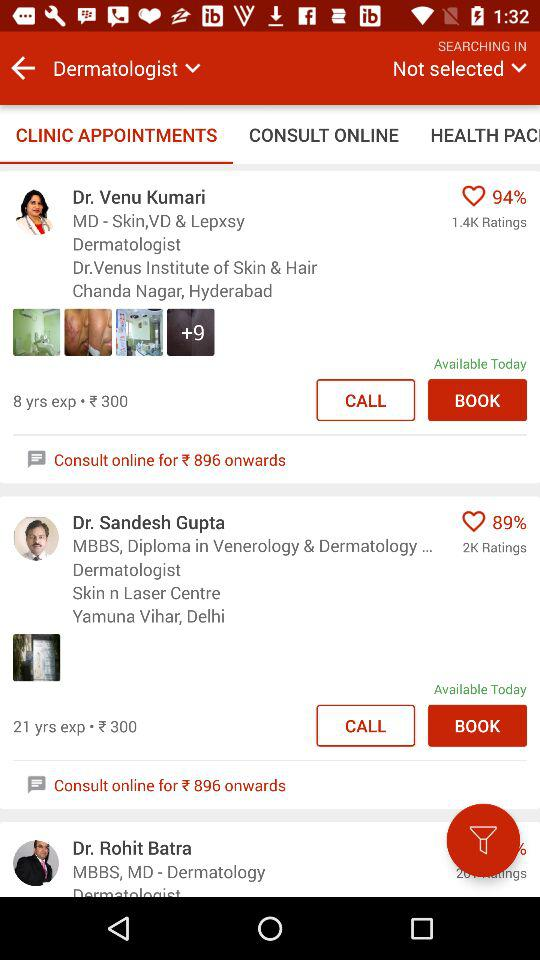What is the percentage of likes for Dr. Venu Kumari? The percentage of likes for Dr. Venu Kumari is 94. 